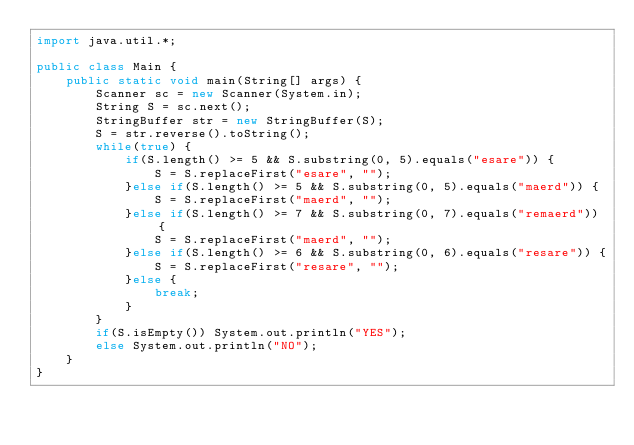Convert code to text. <code><loc_0><loc_0><loc_500><loc_500><_Java_>import java.util.*;
 
public class Main {
    public static void main(String[] args) {
        Scanner sc = new Scanner(System.in);
        String S = sc.next();
        StringBuffer str = new StringBuffer(S);
        S = str.reverse().toString();
        while(true) {
            if(S.length() >= 5 && S.substring(0, 5).equals("esare")) {
                S = S.replaceFirst("esare", "");
            }else if(S.length() >= 5 && S.substring(0, 5).equals("maerd")) {
                S = S.replaceFirst("maerd", "");
            }else if(S.length() >= 7 && S.substring(0, 7).equals("remaerd")) {
                S = S.replaceFirst("maerd", "");
            }else if(S.length() >= 6 && S.substring(0, 6).equals("resare")) {
                S = S.replaceFirst("resare", "");
            }else {
                break;
            }
        }
        if(S.isEmpty()) System.out.println("YES");
        else System.out.println("NO");
    }
}</code> 